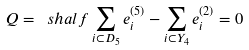Convert formula to latex. <formula><loc_0><loc_0><loc_500><loc_500>Q = \ s h a l f \sum _ { i \subset D _ { 5 } } e _ { i } ^ { ( 5 ) } - \sum _ { i \subset Y _ { 4 } } e _ { i } ^ { ( 2 ) } = 0</formula> 